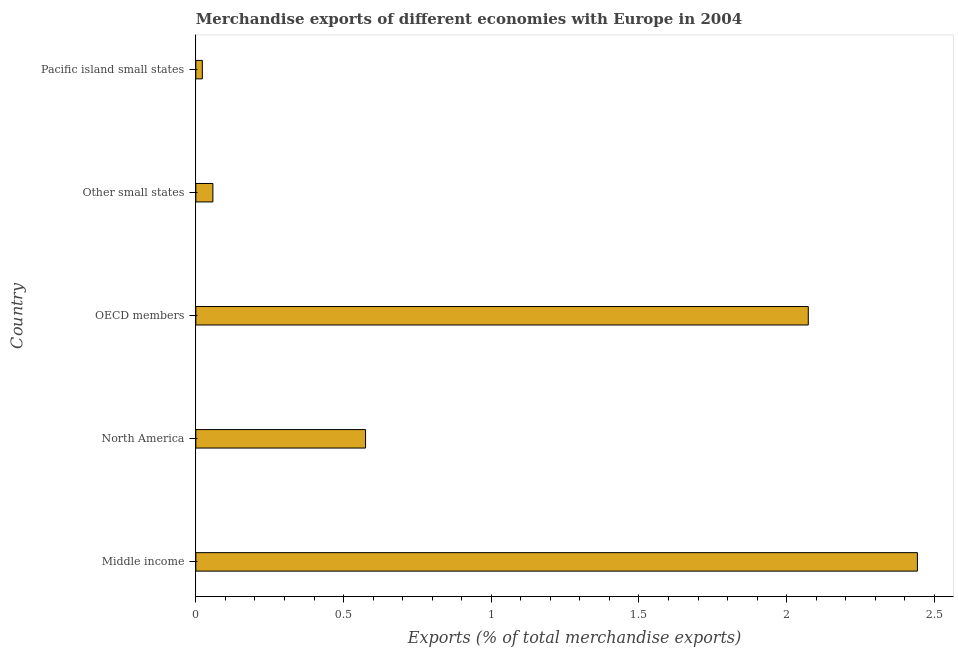What is the title of the graph?
Your answer should be compact. Merchandise exports of different economies with Europe in 2004. What is the label or title of the X-axis?
Your answer should be very brief. Exports (% of total merchandise exports). What is the merchandise exports in Other small states?
Provide a succinct answer. 0.06. Across all countries, what is the maximum merchandise exports?
Make the answer very short. 2.44. Across all countries, what is the minimum merchandise exports?
Keep it short and to the point. 0.02. In which country was the merchandise exports minimum?
Offer a terse response. Pacific island small states. What is the sum of the merchandise exports?
Offer a terse response. 5.17. What is the difference between the merchandise exports in North America and Pacific island small states?
Your answer should be very brief. 0.55. What is the average merchandise exports per country?
Your answer should be compact. 1.03. What is the median merchandise exports?
Your answer should be compact. 0.57. What is the ratio of the merchandise exports in Middle income to that in North America?
Offer a very short reply. 4.25. Is the merchandise exports in Middle income less than that in North America?
Your answer should be very brief. No. What is the difference between the highest and the second highest merchandise exports?
Ensure brevity in your answer.  0.37. What is the difference between the highest and the lowest merchandise exports?
Your answer should be compact. 2.42. In how many countries, is the merchandise exports greater than the average merchandise exports taken over all countries?
Provide a short and direct response. 2. How many bars are there?
Offer a terse response. 5. Are all the bars in the graph horizontal?
Your answer should be very brief. Yes. What is the difference between two consecutive major ticks on the X-axis?
Offer a terse response. 0.5. Are the values on the major ticks of X-axis written in scientific E-notation?
Your response must be concise. No. What is the Exports (% of total merchandise exports) in Middle income?
Your response must be concise. 2.44. What is the Exports (% of total merchandise exports) in North America?
Your response must be concise. 0.57. What is the Exports (% of total merchandise exports) in OECD members?
Your answer should be very brief. 2.07. What is the Exports (% of total merchandise exports) of Other small states?
Keep it short and to the point. 0.06. What is the Exports (% of total merchandise exports) in Pacific island small states?
Your answer should be compact. 0.02. What is the difference between the Exports (% of total merchandise exports) in Middle income and North America?
Your response must be concise. 1.87. What is the difference between the Exports (% of total merchandise exports) in Middle income and OECD members?
Keep it short and to the point. 0.37. What is the difference between the Exports (% of total merchandise exports) in Middle income and Other small states?
Provide a succinct answer. 2.38. What is the difference between the Exports (% of total merchandise exports) in Middle income and Pacific island small states?
Your answer should be compact. 2.42. What is the difference between the Exports (% of total merchandise exports) in North America and OECD members?
Ensure brevity in your answer.  -1.5. What is the difference between the Exports (% of total merchandise exports) in North America and Other small states?
Provide a succinct answer. 0.52. What is the difference between the Exports (% of total merchandise exports) in North America and Pacific island small states?
Your answer should be compact. 0.55. What is the difference between the Exports (% of total merchandise exports) in OECD members and Other small states?
Offer a very short reply. 2.02. What is the difference between the Exports (% of total merchandise exports) in OECD members and Pacific island small states?
Your answer should be compact. 2.05. What is the difference between the Exports (% of total merchandise exports) in Other small states and Pacific island small states?
Give a very brief answer. 0.04. What is the ratio of the Exports (% of total merchandise exports) in Middle income to that in North America?
Your response must be concise. 4.25. What is the ratio of the Exports (% of total merchandise exports) in Middle income to that in OECD members?
Your answer should be compact. 1.18. What is the ratio of the Exports (% of total merchandise exports) in Middle income to that in Other small states?
Your answer should be very brief. 42.29. What is the ratio of the Exports (% of total merchandise exports) in Middle income to that in Pacific island small states?
Make the answer very short. 110.76. What is the ratio of the Exports (% of total merchandise exports) in North America to that in OECD members?
Ensure brevity in your answer.  0.28. What is the ratio of the Exports (% of total merchandise exports) in North America to that in Other small states?
Your answer should be compact. 9.95. What is the ratio of the Exports (% of total merchandise exports) in North America to that in Pacific island small states?
Ensure brevity in your answer.  26.05. What is the ratio of the Exports (% of total merchandise exports) in OECD members to that in Other small states?
Provide a succinct answer. 35.9. What is the ratio of the Exports (% of total merchandise exports) in OECD members to that in Pacific island small states?
Keep it short and to the point. 94. What is the ratio of the Exports (% of total merchandise exports) in Other small states to that in Pacific island small states?
Your answer should be very brief. 2.62. 